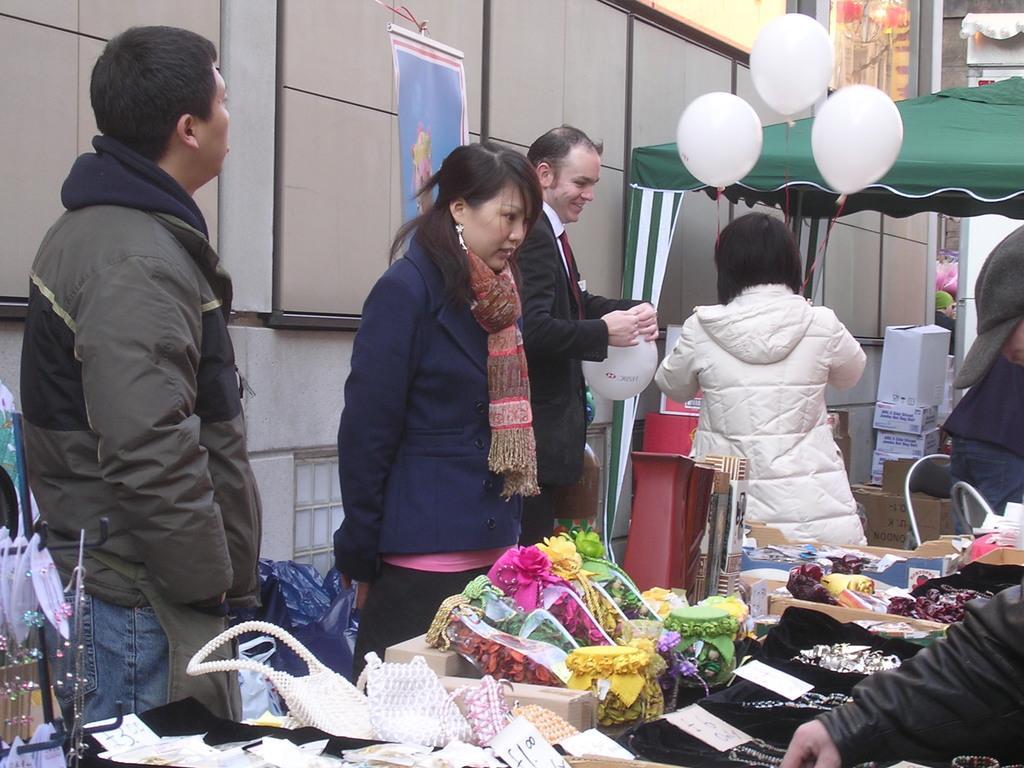How would you summarize this image in a sentence or two? In this image, there are few people standing. At the bottom of the image, there are handbags, ornaments and few other things. On the right side of the image, I can see a canopy tent and the white balloons. There are cardboard boxes and few other objects under the canopy tent. In the background, I can see a banner and a building wall. 